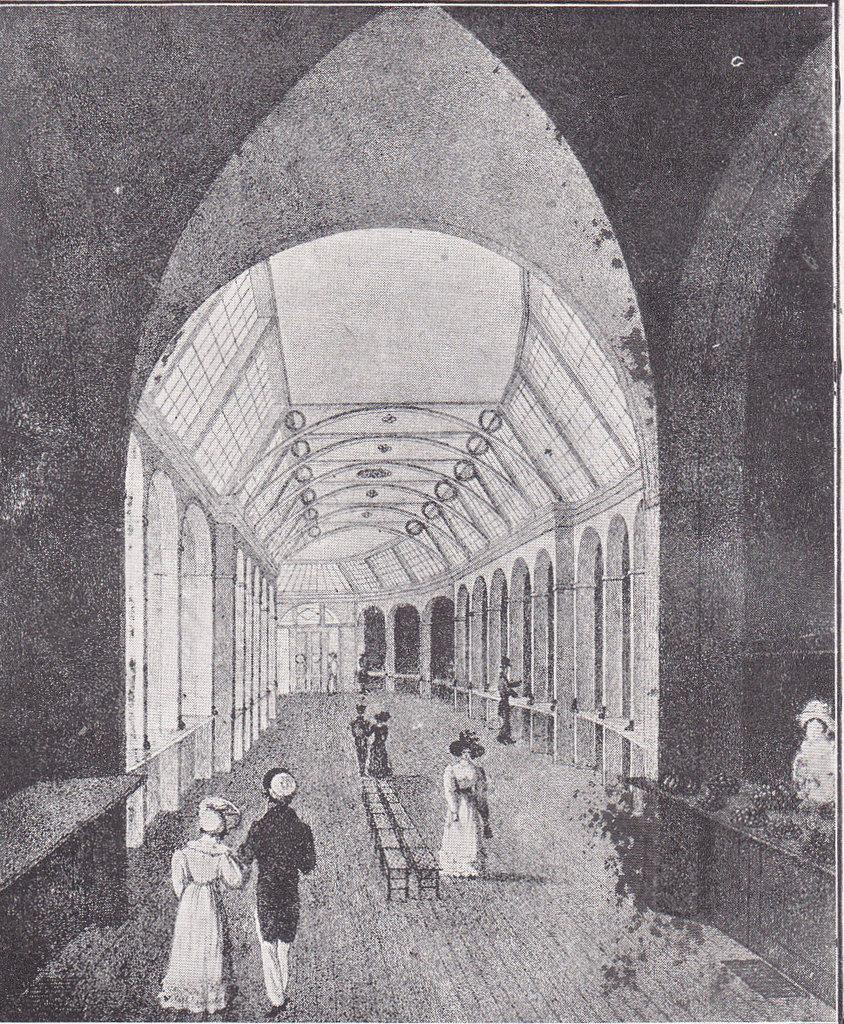What type of image is shown in the picture? The image contains a black and white photograph. What is the main subject of the photograph? The photograph depicts a long hall. Are there any people in the photograph? Yes, there is a man and a woman walking in the front of the hall. What architectural features can be seen in the hall? There are arch-type pillars in the hall. What is the ceiling of the hall like? There is a roof in the hall. What role does the mother play in the photograph? There is no mention of a mother in the photograph, as it only depicts a man and a woman walking in the hall. How does the actor feel about the afterthought in the scene? There is no actor or scene in the photograph, as it is a black and white image of a long hall with a man and a woman walking. 